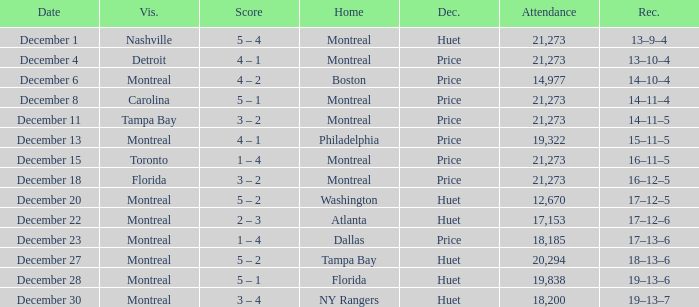What is the record on December 4? 13–10–4. 